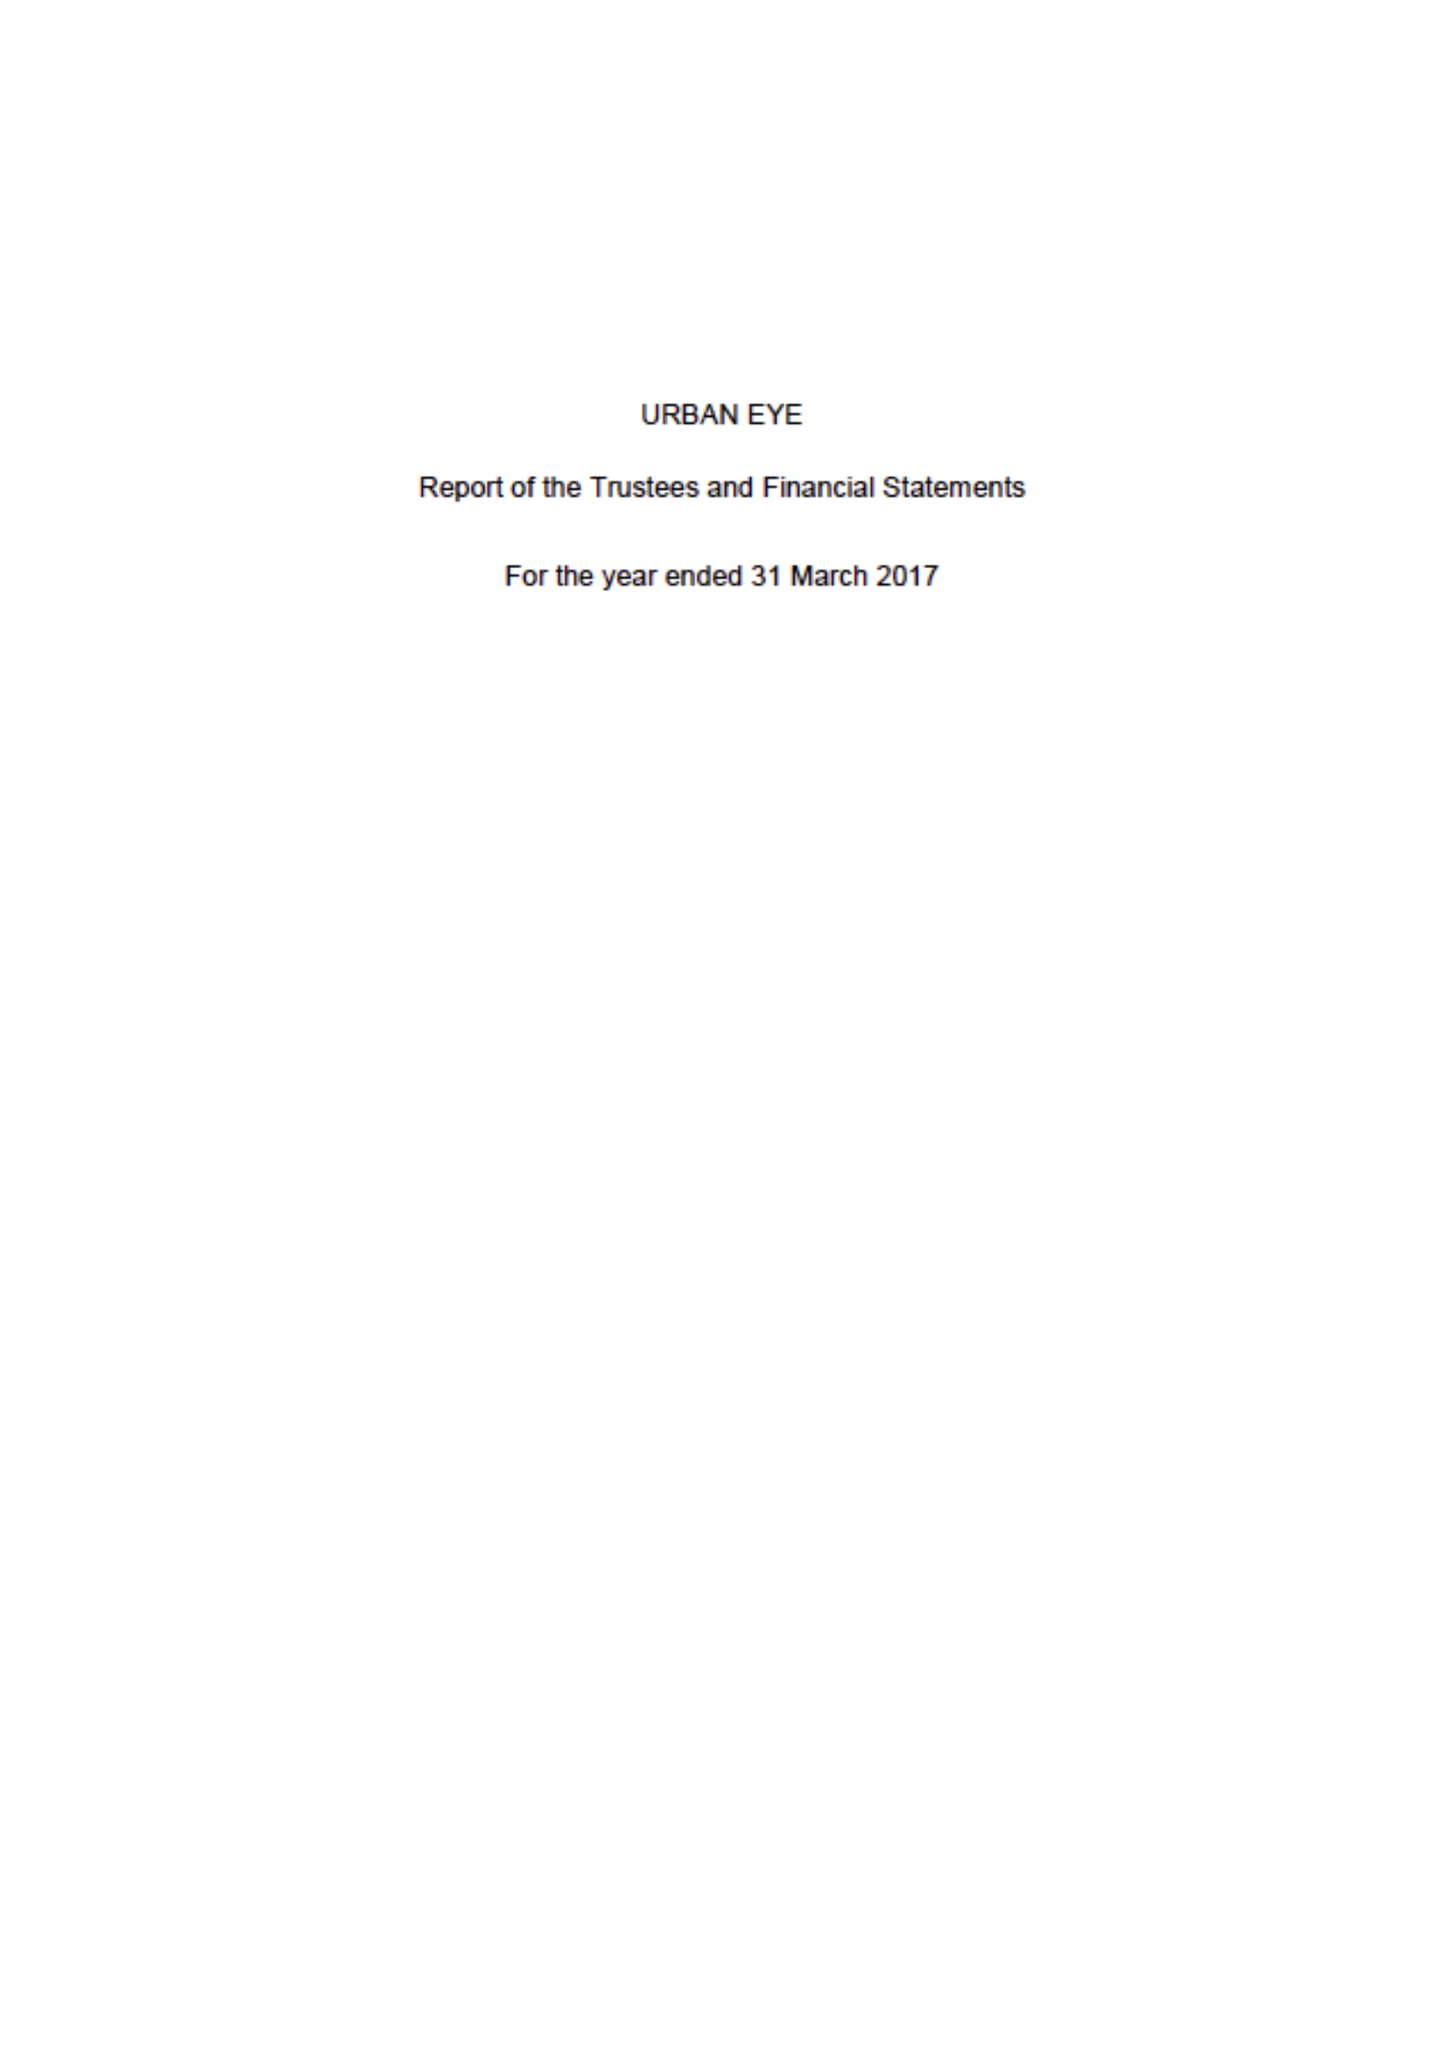What is the value for the address__street_line?
Answer the question using a single word or phrase. WHITCHURCH ROAD 